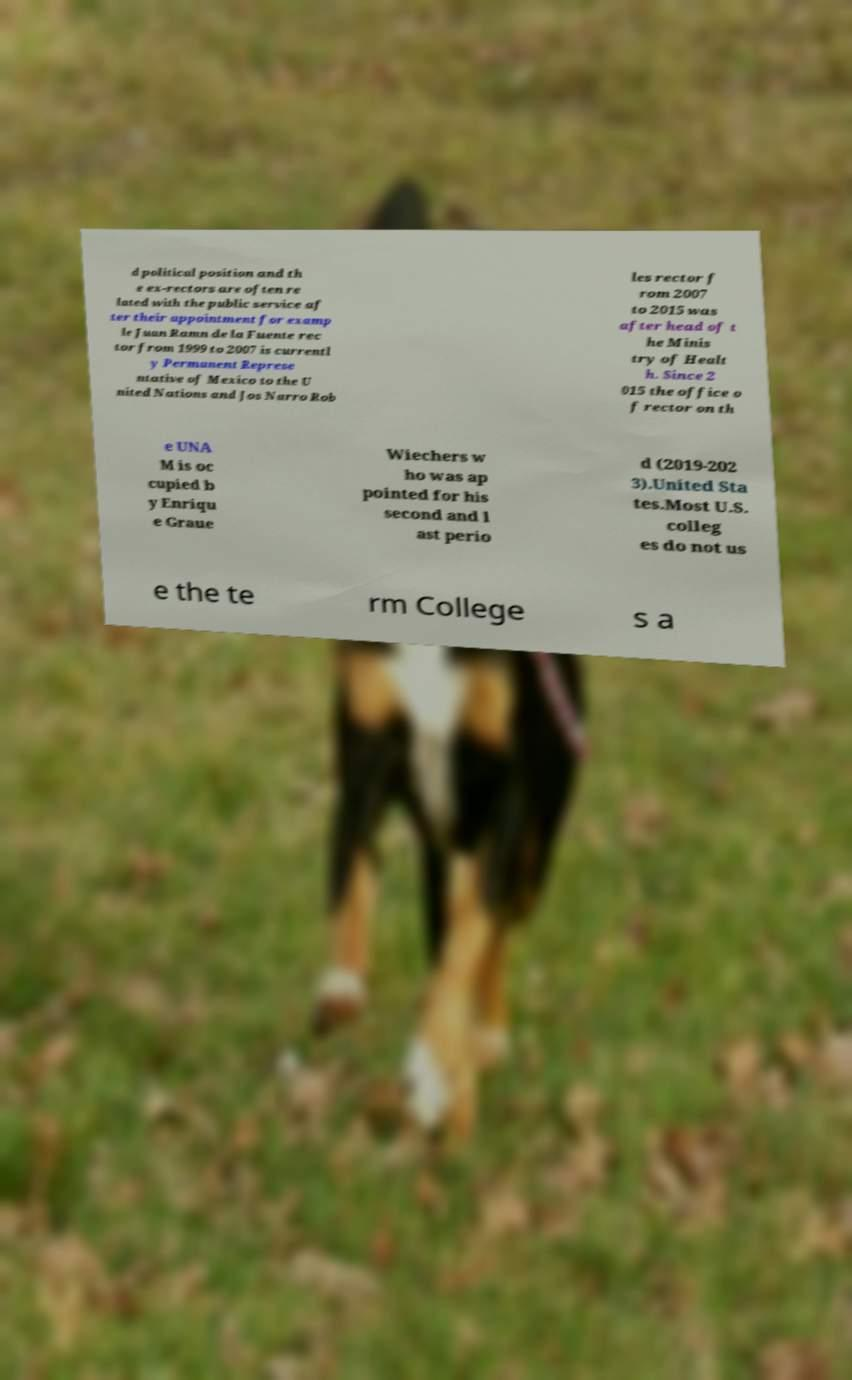Please identify and transcribe the text found in this image. d political position and th e ex-rectors are often re lated with the public service af ter their appointment for examp le Juan Ramn de la Fuente rec tor from 1999 to 2007 is currentl y Permanent Represe ntative of Mexico to the U nited Nations and Jos Narro Rob les rector f rom 2007 to 2015 was after head of t he Minis try of Healt h. Since 2 015 the office o f rector on th e UNA M is oc cupied b y Enriqu e Graue Wiechers w ho was ap pointed for his second and l ast perio d (2019-202 3).United Sta tes.Most U.S. colleg es do not us e the te rm College s a 